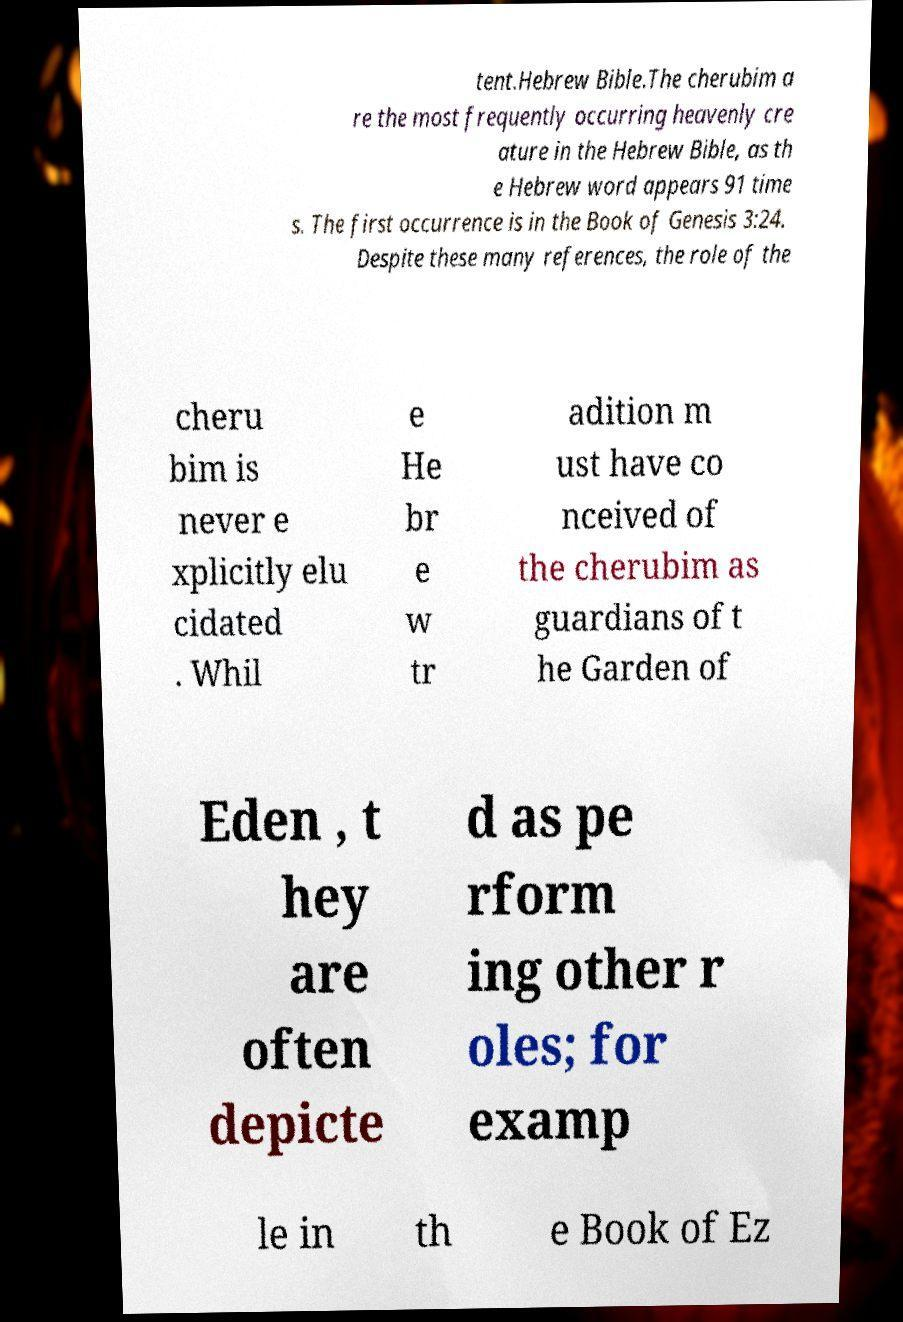I need the written content from this picture converted into text. Can you do that? tent.Hebrew Bible.The cherubim a re the most frequently occurring heavenly cre ature in the Hebrew Bible, as th e Hebrew word appears 91 time s. The first occurrence is in the Book of Genesis 3:24. Despite these many references, the role of the cheru bim is never e xplicitly elu cidated . Whil e He br e w tr adition m ust have co nceived of the cherubim as guardians of t he Garden of Eden , t hey are often depicte d as pe rform ing other r oles; for examp le in th e Book of Ez 